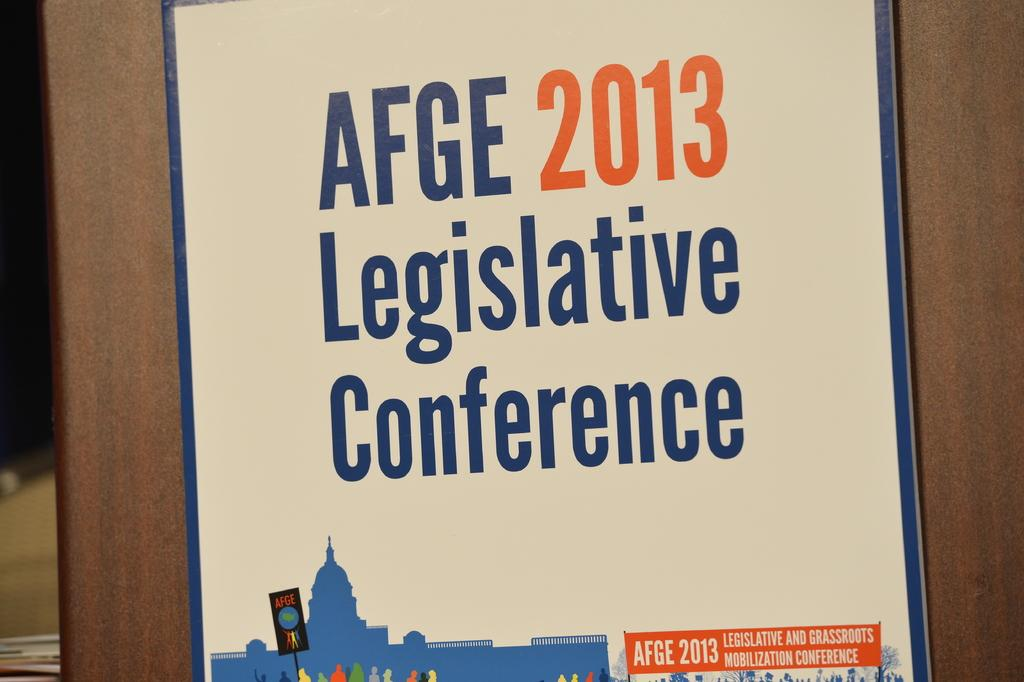<image>
Describe the image concisely. A poster that says AFGE 2013 Legislative Conference on it. 